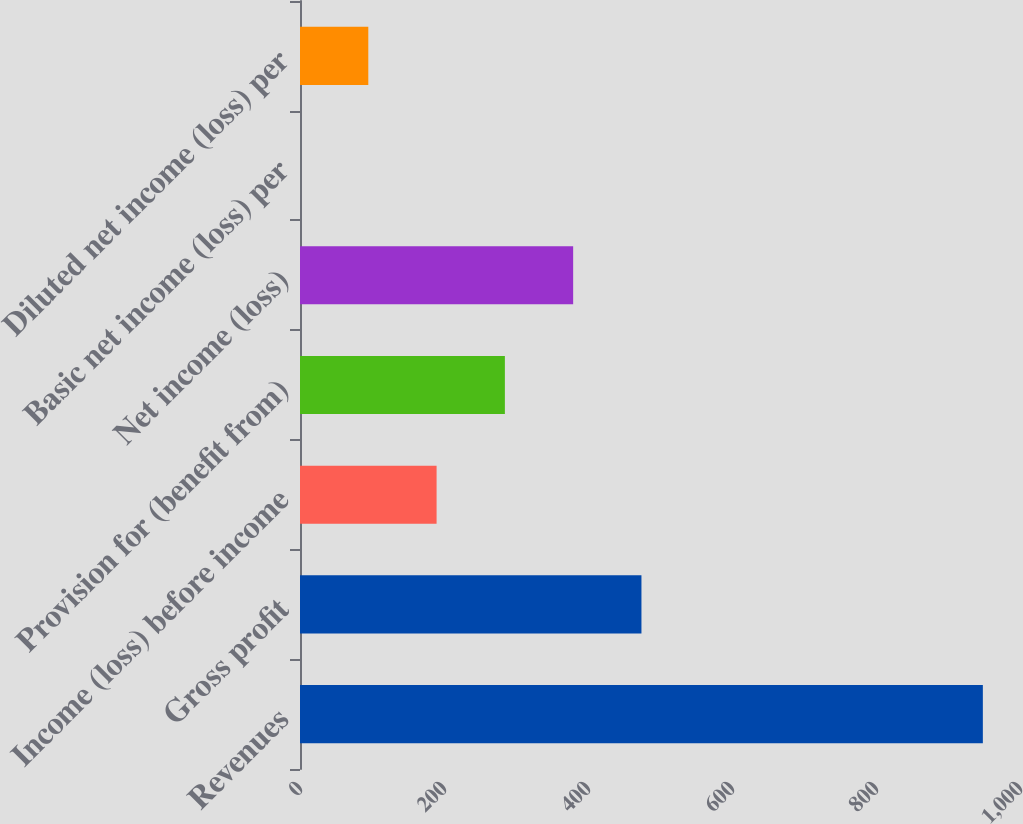Convert chart. <chart><loc_0><loc_0><loc_500><loc_500><bar_chart><fcel>Revenues<fcel>Gross profit<fcel>Income (loss) before income<fcel>Provision for (benefit from)<fcel>Net income (loss)<fcel>Basic net income (loss) per<fcel>Diluted net income (loss) per<nl><fcel>948.4<fcel>474.23<fcel>189.71<fcel>284.55<fcel>379.39<fcel>0.03<fcel>94.87<nl></chart> 